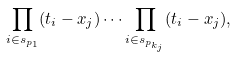<formula> <loc_0><loc_0><loc_500><loc_500>\prod _ { i \in s _ { p _ { 1 } } } ( t _ { i } - x _ { j } ) \dots \prod _ { i \in s _ { p _ { k _ { j } } } } ( t _ { i } - x _ { j } ) ,</formula> 